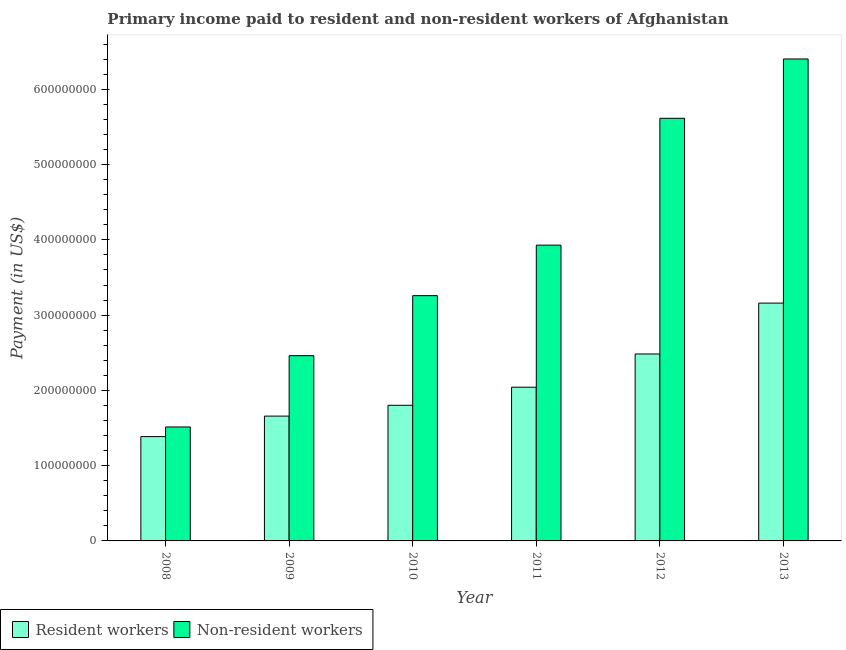Are the number of bars on each tick of the X-axis equal?
Your answer should be compact. Yes. What is the label of the 2nd group of bars from the left?
Offer a terse response. 2009. In how many cases, is the number of bars for a given year not equal to the number of legend labels?
Make the answer very short. 0. What is the payment made to non-resident workers in 2012?
Your response must be concise. 5.62e+08. Across all years, what is the maximum payment made to resident workers?
Keep it short and to the point. 3.16e+08. Across all years, what is the minimum payment made to non-resident workers?
Ensure brevity in your answer.  1.51e+08. In which year was the payment made to non-resident workers maximum?
Your answer should be compact. 2013. In which year was the payment made to resident workers minimum?
Give a very brief answer. 2008. What is the total payment made to resident workers in the graph?
Offer a terse response. 1.25e+09. What is the difference between the payment made to resident workers in 2008 and that in 2011?
Provide a short and direct response. -6.56e+07. What is the difference between the payment made to non-resident workers in 2011 and the payment made to resident workers in 2010?
Provide a succinct answer. 6.71e+07. What is the average payment made to resident workers per year?
Offer a very short reply. 2.09e+08. In the year 2010, what is the difference between the payment made to non-resident workers and payment made to resident workers?
Provide a short and direct response. 0. What is the ratio of the payment made to non-resident workers in 2010 to that in 2011?
Give a very brief answer. 0.83. Is the payment made to resident workers in 2008 less than that in 2011?
Offer a terse response. Yes. What is the difference between the highest and the second highest payment made to non-resident workers?
Give a very brief answer. 7.88e+07. What is the difference between the highest and the lowest payment made to non-resident workers?
Make the answer very short. 4.89e+08. In how many years, is the payment made to non-resident workers greater than the average payment made to non-resident workers taken over all years?
Provide a short and direct response. 3. Is the sum of the payment made to resident workers in 2010 and 2012 greater than the maximum payment made to non-resident workers across all years?
Your answer should be very brief. Yes. What does the 2nd bar from the left in 2012 represents?
Your answer should be compact. Non-resident workers. What does the 2nd bar from the right in 2009 represents?
Provide a short and direct response. Resident workers. How many bars are there?
Your answer should be compact. 12. How many years are there in the graph?
Make the answer very short. 6. Are the values on the major ticks of Y-axis written in scientific E-notation?
Provide a succinct answer. No. Where does the legend appear in the graph?
Offer a very short reply. Bottom left. How many legend labels are there?
Your answer should be compact. 2. How are the legend labels stacked?
Make the answer very short. Horizontal. What is the title of the graph?
Provide a succinct answer. Primary income paid to resident and non-resident workers of Afghanistan. Does "GDP at market prices" appear as one of the legend labels in the graph?
Your answer should be compact. No. What is the label or title of the X-axis?
Provide a short and direct response. Year. What is the label or title of the Y-axis?
Provide a short and direct response. Payment (in US$). What is the Payment (in US$) of Resident workers in 2008?
Keep it short and to the point. 1.39e+08. What is the Payment (in US$) of Non-resident workers in 2008?
Provide a succinct answer. 1.51e+08. What is the Payment (in US$) of Resident workers in 2009?
Make the answer very short. 1.66e+08. What is the Payment (in US$) in Non-resident workers in 2009?
Your response must be concise. 2.46e+08. What is the Payment (in US$) in Resident workers in 2010?
Provide a succinct answer. 1.80e+08. What is the Payment (in US$) in Non-resident workers in 2010?
Your response must be concise. 3.26e+08. What is the Payment (in US$) in Resident workers in 2011?
Offer a very short reply. 2.04e+08. What is the Payment (in US$) in Non-resident workers in 2011?
Provide a short and direct response. 3.93e+08. What is the Payment (in US$) of Resident workers in 2012?
Make the answer very short. 2.48e+08. What is the Payment (in US$) in Non-resident workers in 2012?
Offer a very short reply. 5.62e+08. What is the Payment (in US$) of Resident workers in 2013?
Offer a terse response. 3.16e+08. What is the Payment (in US$) of Non-resident workers in 2013?
Give a very brief answer. 6.40e+08. Across all years, what is the maximum Payment (in US$) of Resident workers?
Offer a terse response. 3.16e+08. Across all years, what is the maximum Payment (in US$) in Non-resident workers?
Keep it short and to the point. 6.40e+08. Across all years, what is the minimum Payment (in US$) in Resident workers?
Provide a short and direct response. 1.39e+08. Across all years, what is the minimum Payment (in US$) of Non-resident workers?
Ensure brevity in your answer.  1.51e+08. What is the total Payment (in US$) in Resident workers in the graph?
Ensure brevity in your answer.  1.25e+09. What is the total Payment (in US$) in Non-resident workers in the graph?
Keep it short and to the point. 2.32e+09. What is the difference between the Payment (in US$) in Resident workers in 2008 and that in 2009?
Ensure brevity in your answer.  -2.72e+07. What is the difference between the Payment (in US$) in Non-resident workers in 2008 and that in 2009?
Offer a terse response. -9.47e+07. What is the difference between the Payment (in US$) in Resident workers in 2008 and that in 2010?
Your answer should be very brief. -4.16e+07. What is the difference between the Payment (in US$) of Non-resident workers in 2008 and that in 2010?
Make the answer very short. -1.75e+08. What is the difference between the Payment (in US$) in Resident workers in 2008 and that in 2011?
Give a very brief answer. -6.56e+07. What is the difference between the Payment (in US$) in Non-resident workers in 2008 and that in 2011?
Your answer should be compact. -2.42e+08. What is the difference between the Payment (in US$) in Resident workers in 2008 and that in 2012?
Ensure brevity in your answer.  -1.10e+08. What is the difference between the Payment (in US$) in Non-resident workers in 2008 and that in 2012?
Provide a short and direct response. -4.10e+08. What is the difference between the Payment (in US$) of Resident workers in 2008 and that in 2013?
Provide a succinct answer. -1.77e+08. What is the difference between the Payment (in US$) of Non-resident workers in 2008 and that in 2013?
Offer a very short reply. -4.89e+08. What is the difference between the Payment (in US$) of Resident workers in 2009 and that in 2010?
Provide a succinct answer. -1.44e+07. What is the difference between the Payment (in US$) in Non-resident workers in 2009 and that in 2010?
Provide a succinct answer. -7.98e+07. What is the difference between the Payment (in US$) of Resident workers in 2009 and that in 2011?
Provide a succinct answer. -3.84e+07. What is the difference between the Payment (in US$) of Non-resident workers in 2009 and that in 2011?
Offer a very short reply. -1.47e+08. What is the difference between the Payment (in US$) in Resident workers in 2009 and that in 2012?
Your response must be concise. -8.26e+07. What is the difference between the Payment (in US$) of Non-resident workers in 2009 and that in 2012?
Make the answer very short. -3.15e+08. What is the difference between the Payment (in US$) in Resident workers in 2009 and that in 2013?
Give a very brief answer. -1.50e+08. What is the difference between the Payment (in US$) in Non-resident workers in 2009 and that in 2013?
Provide a succinct answer. -3.94e+08. What is the difference between the Payment (in US$) of Resident workers in 2010 and that in 2011?
Offer a very short reply. -2.40e+07. What is the difference between the Payment (in US$) in Non-resident workers in 2010 and that in 2011?
Your answer should be very brief. -6.71e+07. What is the difference between the Payment (in US$) of Resident workers in 2010 and that in 2012?
Your answer should be very brief. -6.82e+07. What is the difference between the Payment (in US$) of Non-resident workers in 2010 and that in 2012?
Your answer should be compact. -2.36e+08. What is the difference between the Payment (in US$) in Resident workers in 2010 and that in 2013?
Offer a terse response. -1.36e+08. What is the difference between the Payment (in US$) in Non-resident workers in 2010 and that in 2013?
Your answer should be very brief. -3.14e+08. What is the difference between the Payment (in US$) in Resident workers in 2011 and that in 2012?
Your answer should be compact. -4.41e+07. What is the difference between the Payment (in US$) in Non-resident workers in 2011 and that in 2012?
Ensure brevity in your answer.  -1.69e+08. What is the difference between the Payment (in US$) in Resident workers in 2011 and that in 2013?
Keep it short and to the point. -1.12e+08. What is the difference between the Payment (in US$) in Non-resident workers in 2011 and that in 2013?
Your response must be concise. -2.47e+08. What is the difference between the Payment (in US$) in Resident workers in 2012 and that in 2013?
Give a very brief answer. -6.76e+07. What is the difference between the Payment (in US$) of Non-resident workers in 2012 and that in 2013?
Provide a succinct answer. -7.88e+07. What is the difference between the Payment (in US$) of Resident workers in 2008 and the Payment (in US$) of Non-resident workers in 2009?
Ensure brevity in your answer.  -1.08e+08. What is the difference between the Payment (in US$) in Resident workers in 2008 and the Payment (in US$) in Non-resident workers in 2010?
Ensure brevity in your answer.  -1.87e+08. What is the difference between the Payment (in US$) in Resident workers in 2008 and the Payment (in US$) in Non-resident workers in 2011?
Provide a succinct answer. -2.54e+08. What is the difference between the Payment (in US$) in Resident workers in 2008 and the Payment (in US$) in Non-resident workers in 2012?
Your answer should be compact. -4.23e+08. What is the difference between the Payment (in US$) in Resident workers in 2008 and the Payment (in US$) in Non-resident workers in 2013?
Give a very brief answer. -5.02e+08. What is the difference between the Payment (in US$) of Resident workers in 2009 and the Payment (in US$) of Non-resident workers in 2010?
Make the answer very short. -1.60e+08. What is the difference between the Payment (in US$) in Resident workers in 2009 and the Payment (in US$) in Non-resident workers in 2011?
Your answer should be very brief. -2.27e+08. What is the difference between the Payment (in US$) in Resident workers in 2009 and the Payment (in US$) in Non-resident workers in 2012?
Provide a succinct answer. -3.96e+08. What is the difference between the Payment (in US$) of Resident workers in 2009 and the Payment (in US$) of Non-resident workers in 2013?
Keep it short and to the point. -4.75e+08. What is the difference between the Payment (in US$) in Resident workers in 2010 and the Payment (in US$) in Non-resident workers in 2011?
Your answer should be compact. -2.13e+08. What is the difference between the Payment (in US$) of Resident workers in 2010 and the Payment (in US$) of Non-resident workers in 2012?
Provide a short and direct response. -3.81e+08. What is the difference between the Payment (in US$) in Resident workers in 2010 and the Payment (in US$) in Non-resident workers in 2013?
Offer a terse response. -4.60e+08. What is the difference between the Payment (in US$) of Resident workers in 2011 and the Payment (in US$) of Non-resident workers in 2012?
Your response must be concise. -3.57e+08. What is the difference between the Payment (in US$) of Resident workers in 2011 and the Payment (in US$) of Non-resident workers in 2013?
Ensure brevity in your answer.  -4.36e+08. What is the difference between the Payment (in US$) in Resident workers in 2012 and the Payment (in US$) in Non-resident workers in 2013?
Your response must be concise. -3.92e+08. What is the average Payment (in US$) of Resident workers per year?
Your answer should be very brief. 2.09e+08. What is the average Payment (in US$) of Non-resident workers per year?
Your response must be concise. 3.86e+08. In the year 2008, what is the difference between the Payment (in US$) of Resident workers and Payment (in US$) of Non-resident workers?
Offer a very short reply. -1.28e+07. In the year 2009, what is the difference between the Payment (in US$) in Resident workers and Payment (in US$) in Non-resident workers?
Give a very brief answer. -8.03e+07. In the year 2010, what is the difference between the Payment (in US$) of Resident workers and Payment (in US$) of Non-resident workers?
Your answer should be compact. -1.46e+08. In the year 2011, what is the difference between the Payment (in US$) in Resident workers and Payment (in US$) in Non-resident workers?
Your response must be concise. -1.89e+08. In the year 2012, what is the difference between the Payment (in US$) in Resident workers and Payment (in US$) in Non-resident workers?
Make the answer very short. -3.13e+08. In the year 2013, what is the difference between the Payment (in US$) in Resident workers and Payment (in US$) in Non-resident workers?
Your answer should be compact. -3.24e+08. What is the ratio of the Payment (in US$) of Resident workers in 2008 to that in 2009?
Provide a short and direct response. 0.84. What is the ratio of the Payment (in US$) in Non-resident workers in 2008 to that in 2009?
Your answer should be very brief. 0.62. What is the ratio of the Payment (in US$) in Resident workers in 2008 to that in 2010?
Your answer should be compact. 0.77. What is the ratio of the Payment (in US$) of Non-resident workers in 2008 to that in 2010?
Make the answer very short. 0.46. What is the ratio of the Payment (in US$) of Resident workers in 2008 to that in 2011?
Your answer should be very brief. 0.68. What is the ratio of the Payment (in US$) of Non-resident workers in 2008 to that in 2011?
Your answer should be very brief. 0.39. What is the ratio of the Payment (in US$) in Resident workers in 2008 to that in 2012?
Keep it short and to the point. 0.56. What is the ratio of the Payment (in US$) in Non-resident workers in 2008 to that in 2012?
Offer a terse response. 0.27. What is the ratio of the Payment (in US$) in Resident workers in 2008 to that in 2013?
Offer a terse response. 0.44. What is the ratio of the Payment (in US$) of Non-resident workers in 2008 to that in 2013?
Keep it short and to the point. 0.24. What is the ratio of the Payment (in US$) of Resident workers in 2009 to that in 2010?
Provide a short and direct response. 0.92. What is the ratio of the Payment (in US$) in Non-resident workers in 2009 to that in 2010?
Your answer should be compact. 0.76. What is the ratio of the Payment (in US$) of Resident workers in 2009 to that in 2011?
Offer a terse response. 0.81. What is the ratio of the Payment (in US$) of Non-resident workers in 2009 to that in 2011?
Offer a very short reply. 0.63. What is the ratio of the Payment (in US$) of Resident workers in 2009 to that in 2012?
Your answer should be very brief. 0.67. What is the ratio of the Payment (in US$) of Non-resident workers in 2009 to that in 2012?
Ensure brevity in your answer.  0.44. What is the ratio of the Payment (in US$) of Resident workers in 2009 to that in 2013?
Keep it short and to the point. 0.52. What is the ratio of the Payment (in US$) in Non-resident workers in 2009 to that in 2013?
Your answer should be very brief. 0.38. What is the ratio of the Payment (in US$) in Resident workers in 2010 to that in 2011?
Your answer should be very brief. 0.88. What is the ratio of the Payment (in US$) in Non-resident workers in 2010 to that in 2011?
Keep it short and to the point. 0.83. What is the ratio of the Payment (in US$) in Resident workers in 2010 to that in 2012?
Provide a short and direct response. 0.73. What is the ratio of the Payment (in US$) in Non-resident workers in 2010 to that in 2012?
Offer a terse response. 0.58. What is the ratio of the Payment (in US$) in Resident workers in 2010 to that in 2013?
Make the answer very short. 0.57. What is the ratio of the Payment (in US$) in Non-resident workers in 2010 to that in 2013?
Your answer should be very brief. 0.51. What is the ratio of the Payment (in US$) of Resident workers in 2011 to that in 2012?
Keep it short and to the point. 0.82. What is the ratio of the Payment (in US$) of Non-resident workers in 2011 to that in 2012?
Keep it short and to the point. 0.7. What is the ratio of the Payment (in US$) in Resident workers in 2011 to that in 2013?
Make the answer very short. 0.65. What is the ratio of the Payment (in US$) in Non-resident workers in 2011 to that in 2013?
Offer a terse response. 0.61. What is the ratio of the Payment (in US$) of Resident workers in 2012 to that in 2013?
Make the answer very short. 0.79. What is the ratio of the Payment (in US$) of Non-resident workers in 2012 to that in 2013?
Your answer should be compact. 0.88. What is the difference between the highest and the second highest Payment (in US$) of Resident workers?
Keep it short and to the point. 6.76e+07. What is the difference between the highest and the second highest Payment (in US$) of Non-resident workers?
Provide a short and direct response. 7.88e+07. What is the difference between the highest and the lowest Payment (in US$) in Resident workers?
Your answer should be very brief. 1.77e+08. What is the difference between the highest and the lowest Payment (in US$) in Non-resident workers?
Your response must be concise. 4.89e+08. 